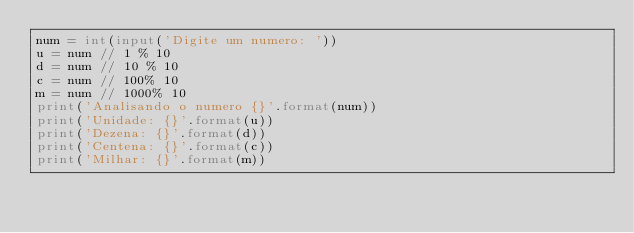Convert code to text. <code><loc_0><loc_0><loc_500><loc_500><_Python_>num = int(input('Digite um numero: '))
u = num // 1 % 10
d = num // 10 % 10
c = num // 100% 10
m = num // 1000% 10
print('Analisando o numero {}'.format(num))
print('Unidade: {}'.format(u))
print('Dezena: {}'.format(d))
print('Centena: {}'.format(c))
print('Milhar: {}'.format(m))</code> 